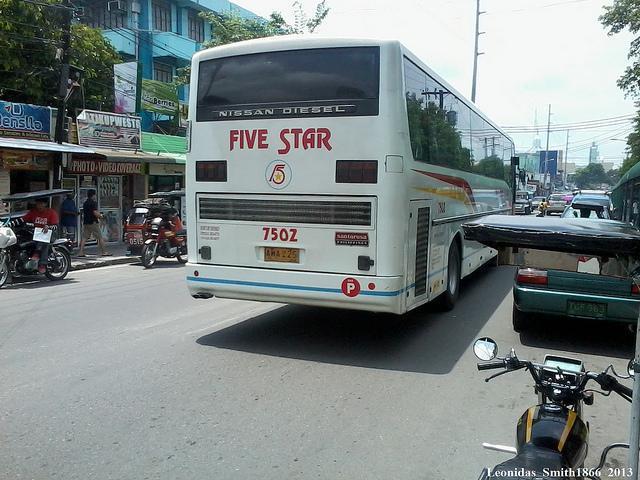How many motorcycles are in the picture?
Give a very brief answer. 2. 